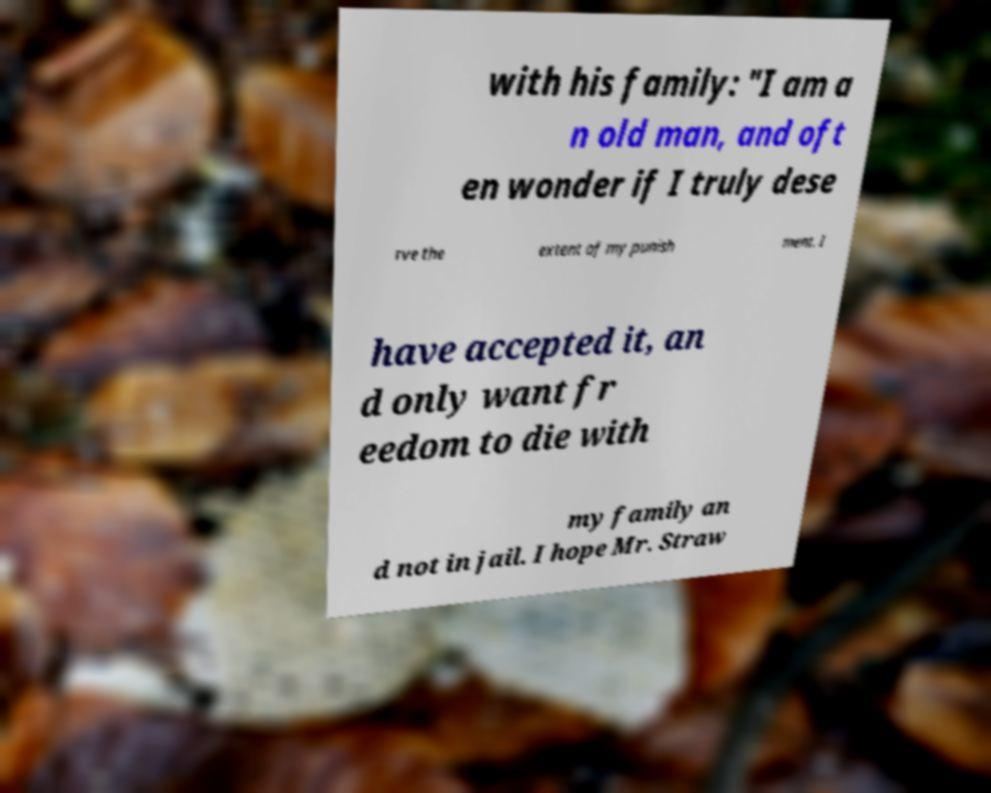Can you read and provide the text displayed in the image?This photo seems to have some interesting text. Can you extract and type it out for me? with his family: "I am a n old man, and oft en wonder if I truly dese rve the extent of my punish ment. I have accepted it, an d only want fr eedom to die with my family an d not in jail. I hope Mr. Straw 